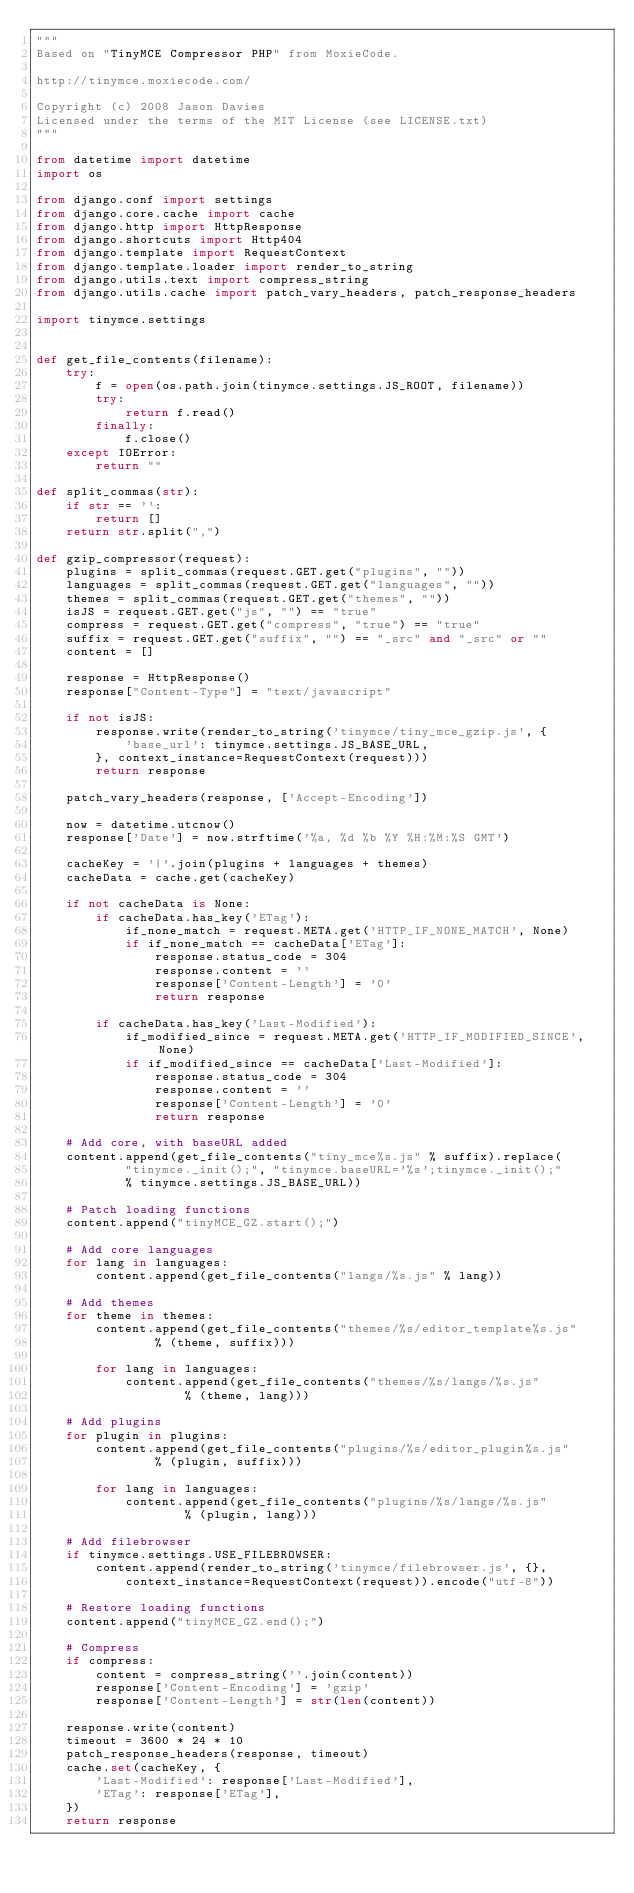Convert code to text. <code><loc_0><loc_0><loc_500><loc_500><_Python_>"""
Based on "TinyMCE Compressor PHP" from MoxieCode.

http://tinymce.moxiecode.com/

Copyright (c) 2008 Jason Davies
Licensed under the terms of the MIT License (see LICENSE.txt)
"""

from datetime import datetime
import os

from django.conf import settings
from django.core.cache import cache
from django.http import HttpResponse
from django.shortcuts import Http404
from django.template import RequestContext
from django.template.loader import render_to_string
from django.utils.text import compress_string
from django.utils.cache import patch_vary_headers, patch_response_headers

import tinymce.settings


def get_file_contents(filename):
    try:
        f = open(os.path.join(tinymce.settings.JS_ROOT, filename))
        try:
            return f.read()
        finally:
            f.close()
    except IOError:
        return ""

def split_commas(str):
    if str == '':
        return []
    return str.split(",")

def gzip_compressor(request):
    plugins = split_commas(request.GET.get("plugins", ""))
    languages = split_commas(request.GET.get("languages", ""))
    themes = split_commas(request.GET.get("themes", ""))
    isJS = request.GET.get("js", "") == "true"
    compress = request.GET.get("compress", "true") == "true"
    suffix = request.GET.get("suffix", "") == "_src" and "_src" or ""
    content = []

    response = HttpResponse()
    response["Content-Type"] = "text/javascript"

    if not isJS:
        response.write(render_to_string('tinymce/tiny_mce_gzip.js', {
            'base_url': tinymce.settings.JS_BASE_URL,
        }, context_instance=RequestContext(request)))
        return response

    patch_vary_headers(response, ['Accept-Encoding'])

    now = datetime.utcnow()
    response['Date'] = now.strftime('%a, %d %b %Y %H:%M:%S GMT')

    cacheKey = '|'.join(plugins + languages + themes)
    cacheData = cache.get(cacheKey)

    if not cacheData is None:
        if cacheData.has_key('ETag'):
            if_none_match = request.META.get('HTTP_IF_NONE_MATCH', None)
            if if_none_match == cacheData['ETag']:
                response.status_code = 304
                response.content = ''
                response['Content-Length'] = '0'
                return response

        if cacheData.has_key('Last-Modified'):
            if_modified_since = request.META.get('HTTP_IF_MODIFIED_SINCE', None)
            if if_modified_since == cacheData['Last-Modified']:
                response.status_code = 304
                response.content = ''
                response['Content-Length'] = '0'
                return response

    # Add core, with baseURL added
    content.append(get_file_contents("tiny_mce%s.js" % suffix).replace(
            "tinymce._init();", "tinymce.baseURL='%s';tinymce._init();"
            % tinymce.settings.JS_BASE_URL))

    # Patch loading functions
    content.append("tinyMCE_GZ.start();")

    # Add core languages
    for lang in languages:
        content.append(get_file_contents("langs/%s.js" % lang))

    # Add themes
    for theme in themes:
        content.append(get_file_contents("themes/%s/editor_template%s.js"
                % (theme, suffix)))

        for lang in languages:
            content.append(get_file_contents("themes/%s/langs/%s.js"
                    % (theme, lang)))

    # Add plugins
    for plugin in plugins:
        content.append(get_file_contents("plugins/%s/editor_plugin%s.js"
                % (plugin, suffix)))

        for lang in languages:
            content.append(get_file_contents("plugins/%s/langs/%s.js"
                    % (plugin, lang)))

    # Add filebrowser
    if tinymce.settings.USE_FILEBROWSER:
        content.append(render_to_string('tinymce/filebrowser.js', {},
            context_instance=RequestContext(request)).encode("utf-8"))

    # Restore loading functions
    content.append("tinyMCE_GZ.end();")

    # Compress
    if compress:
        content = compress_string(''.join(content))
        response['Content-Encoding'] = 'gzip'
        response['Content-Length'] = str(len(content))

    response.write(content)
    timeout = 3600 * 24 * 10
    patch_response_headers(response, timeout)
    cache.set(cacheKey, {
        'Last-Modified': response['Last-Modified'],
        'ETag': response['ETag'],
    })
    return response
</code> 